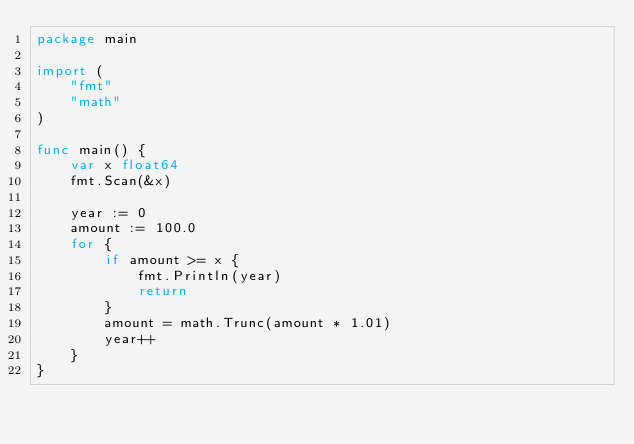Convert code to text. <code><loc_0><loc_0><loc_500><loc_500><_Go_>package main

import (
	"fmt"
	"math"
)

func main() {
	var x float64
	fmt.Scan(&x)

	year := 0
	amount := 100.0
	for {
		if amount >= x {
			fmt.Println(year)
			return
		}
		amount = math.Trunc(amount * 1.01)
		year++
	}
}
</code> 